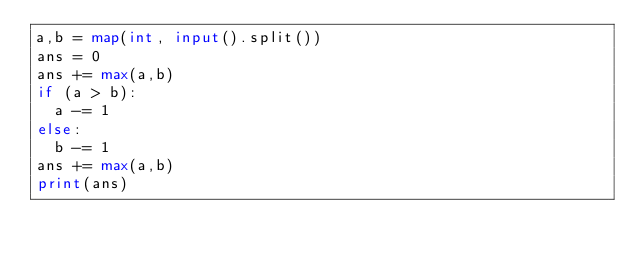Convert code to text. <code><loc_0><loc_0><loc_500><loc_500><_Python_>a,b = map(int, input().split())
ans = 0
ans += max(a,b)
if (a > b):
  a -= 1
else:
  b -= 1
ans += max(a,b)
print(ans)</code> 